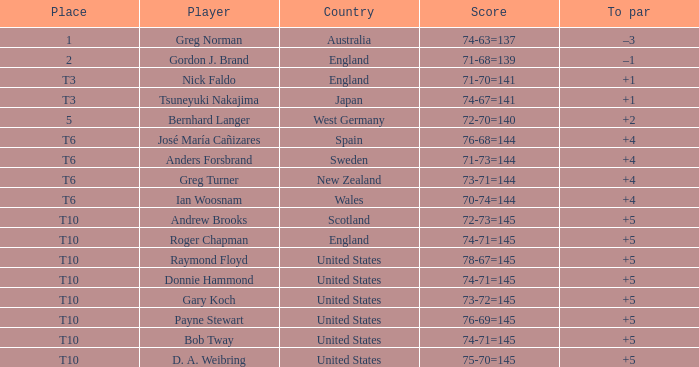Would you be able to parse every entry in this table? {'header': ['Place', 'Player', 'Country', 'Score', 'To par'], 'rows': [['1', 'Greg Norman', 'Australia', '74-63=137', '–3'], ['2', 'Gordon J. Brand', 'England', '71-68=139', '–1'], ['T3', 'Nick Faldo', 'England', '71-70=141', '+1'], ['T3', 'Tsuneyuki Nakajima', 'Japan', '74-67=141', '+1'], ['5', 'Bernhard Langer', 'West Germany', '72-70=140', '+2'], ['T6', 'José María Cañizares', 'Spain', '76-68=144', '+4'], ['T6', 'Anders Forsbrand', 'Sweden', '71-73=144', '+4'], ['T6', 'Greg Turner', 'New Zealand', '73-71=144', '+4'], ['T6', 'Ian Woosnam', 'Wales', '70-74=144', '+4'], ['T10', 'Andrew Brooks', 'Scotland', '72-73=145', '+5'], ['T10', 'Roger Chapman', 'England', '74-71=145', '+5'], ['T10', 'Raymond Floyd', 'United States', '78-67=145', '+5'], ['T10', 'Donnie Hammond', 'United States', '74-71=145', '+5'], ['T10', 'Gary Koch', 'United States', '73-72=145', '+5'], ['T10', 'Payne Stewart', 'United States', '76-69=145', '+5'], ['T10', 'Bob Tway', 'United States', '74-71=145', '+5'], ['T10', 'D. A. Weibring', 'United States', '75-70=145', '+5']]} What country did Raymond Floyd play for? United States. 